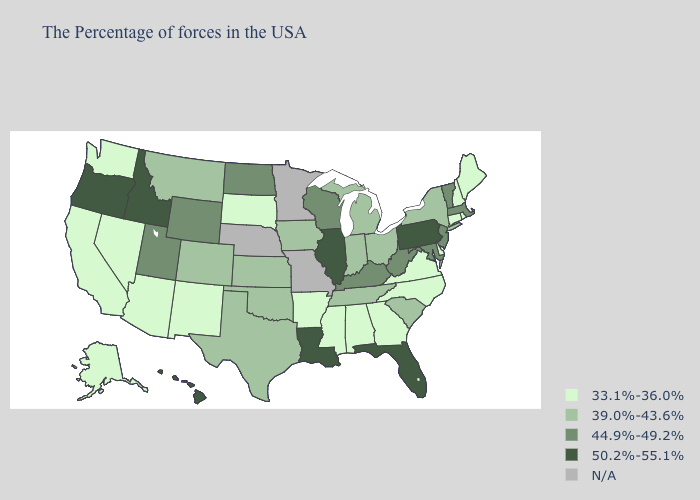What is the value of New Jersey?
Keep it brief. 44.9%-49.2%. What is the highest value in states that border Wisconsin?
Keep it brief. 50.2%-55.1%. Name the states that have a value in the range 50.2%-55.1%?
Concise answer only. Pennsylvania, Florida, Illinois, Louisiana, Idaho, Oregon, Hawaii. What is the lowest value in the West?
Be succinct. 33.1%-36.0%. Does the first symbol in the legend represent the smallest category?
Concise answer only. Yes. What is the highest value in the USA?
Quick response, please. 50.2%-55.1%. Is the legend a continuous bar?
Be succinct. No. What is the highest value in the USA?
Quick response, please. 50.2%-55.1%. What is the value of Washington?
Quick response, please. 33.1%-36.0%. How many symbols are there in the legend?
Write a very short answer. 5. What is the lowest value in the USA?
Answer briefly. 33.1%-36.0%. Among the states that border Illinois , which have the lowest value?
Give a very brief answer. Indiana, Iowa. What is the value of Mississippi?
Quick response, please. 33.1%-36.0%. 